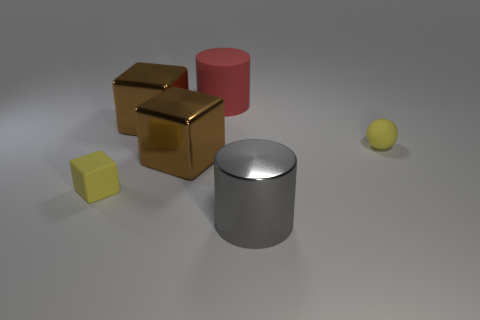Add 3 brown shiny objects. How many objects exist? 9 Subtract all cylinders. How many objects are left? 4 Add 4 big blocks. How many big blocks exist? 6 Subtract 0 purple cubes. How many objects are left? 6 Subtract all rubber spheres. Subtract all red things. How many objects are left? 4 Add 6 large gray metal cylinders. How many large gray metal cylinders are left? 7 